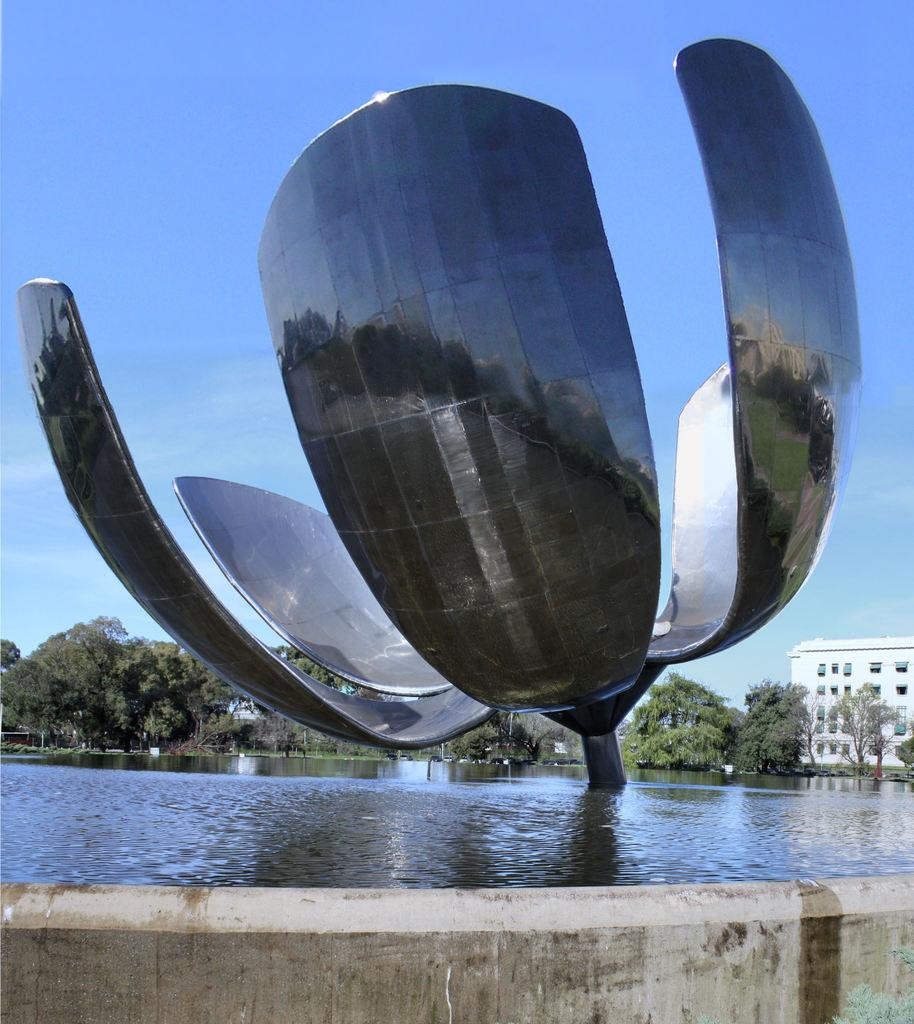What is one of the natural elements present in the image? There is water in the image. What type of vegetation can be seen in the image? There are trees in the image. What color is prominently featured in the image? There is a white color in the image. What type of man-made structure is visible in the image? There is a building in the image. What part of the natural environment is visible in the image? The sky is visible in the image. What type of architectural style is present in the image? An architecture is present in the image. What hobbies do the cave dwellers in the image engage in? There are no cave dwellers present in the image, as it features water, trees, a building, and an architecture. What type of lawyer is depicted in the image? There is no lawyer depicted in the image; it features water, trees, a building, and an architecture. 